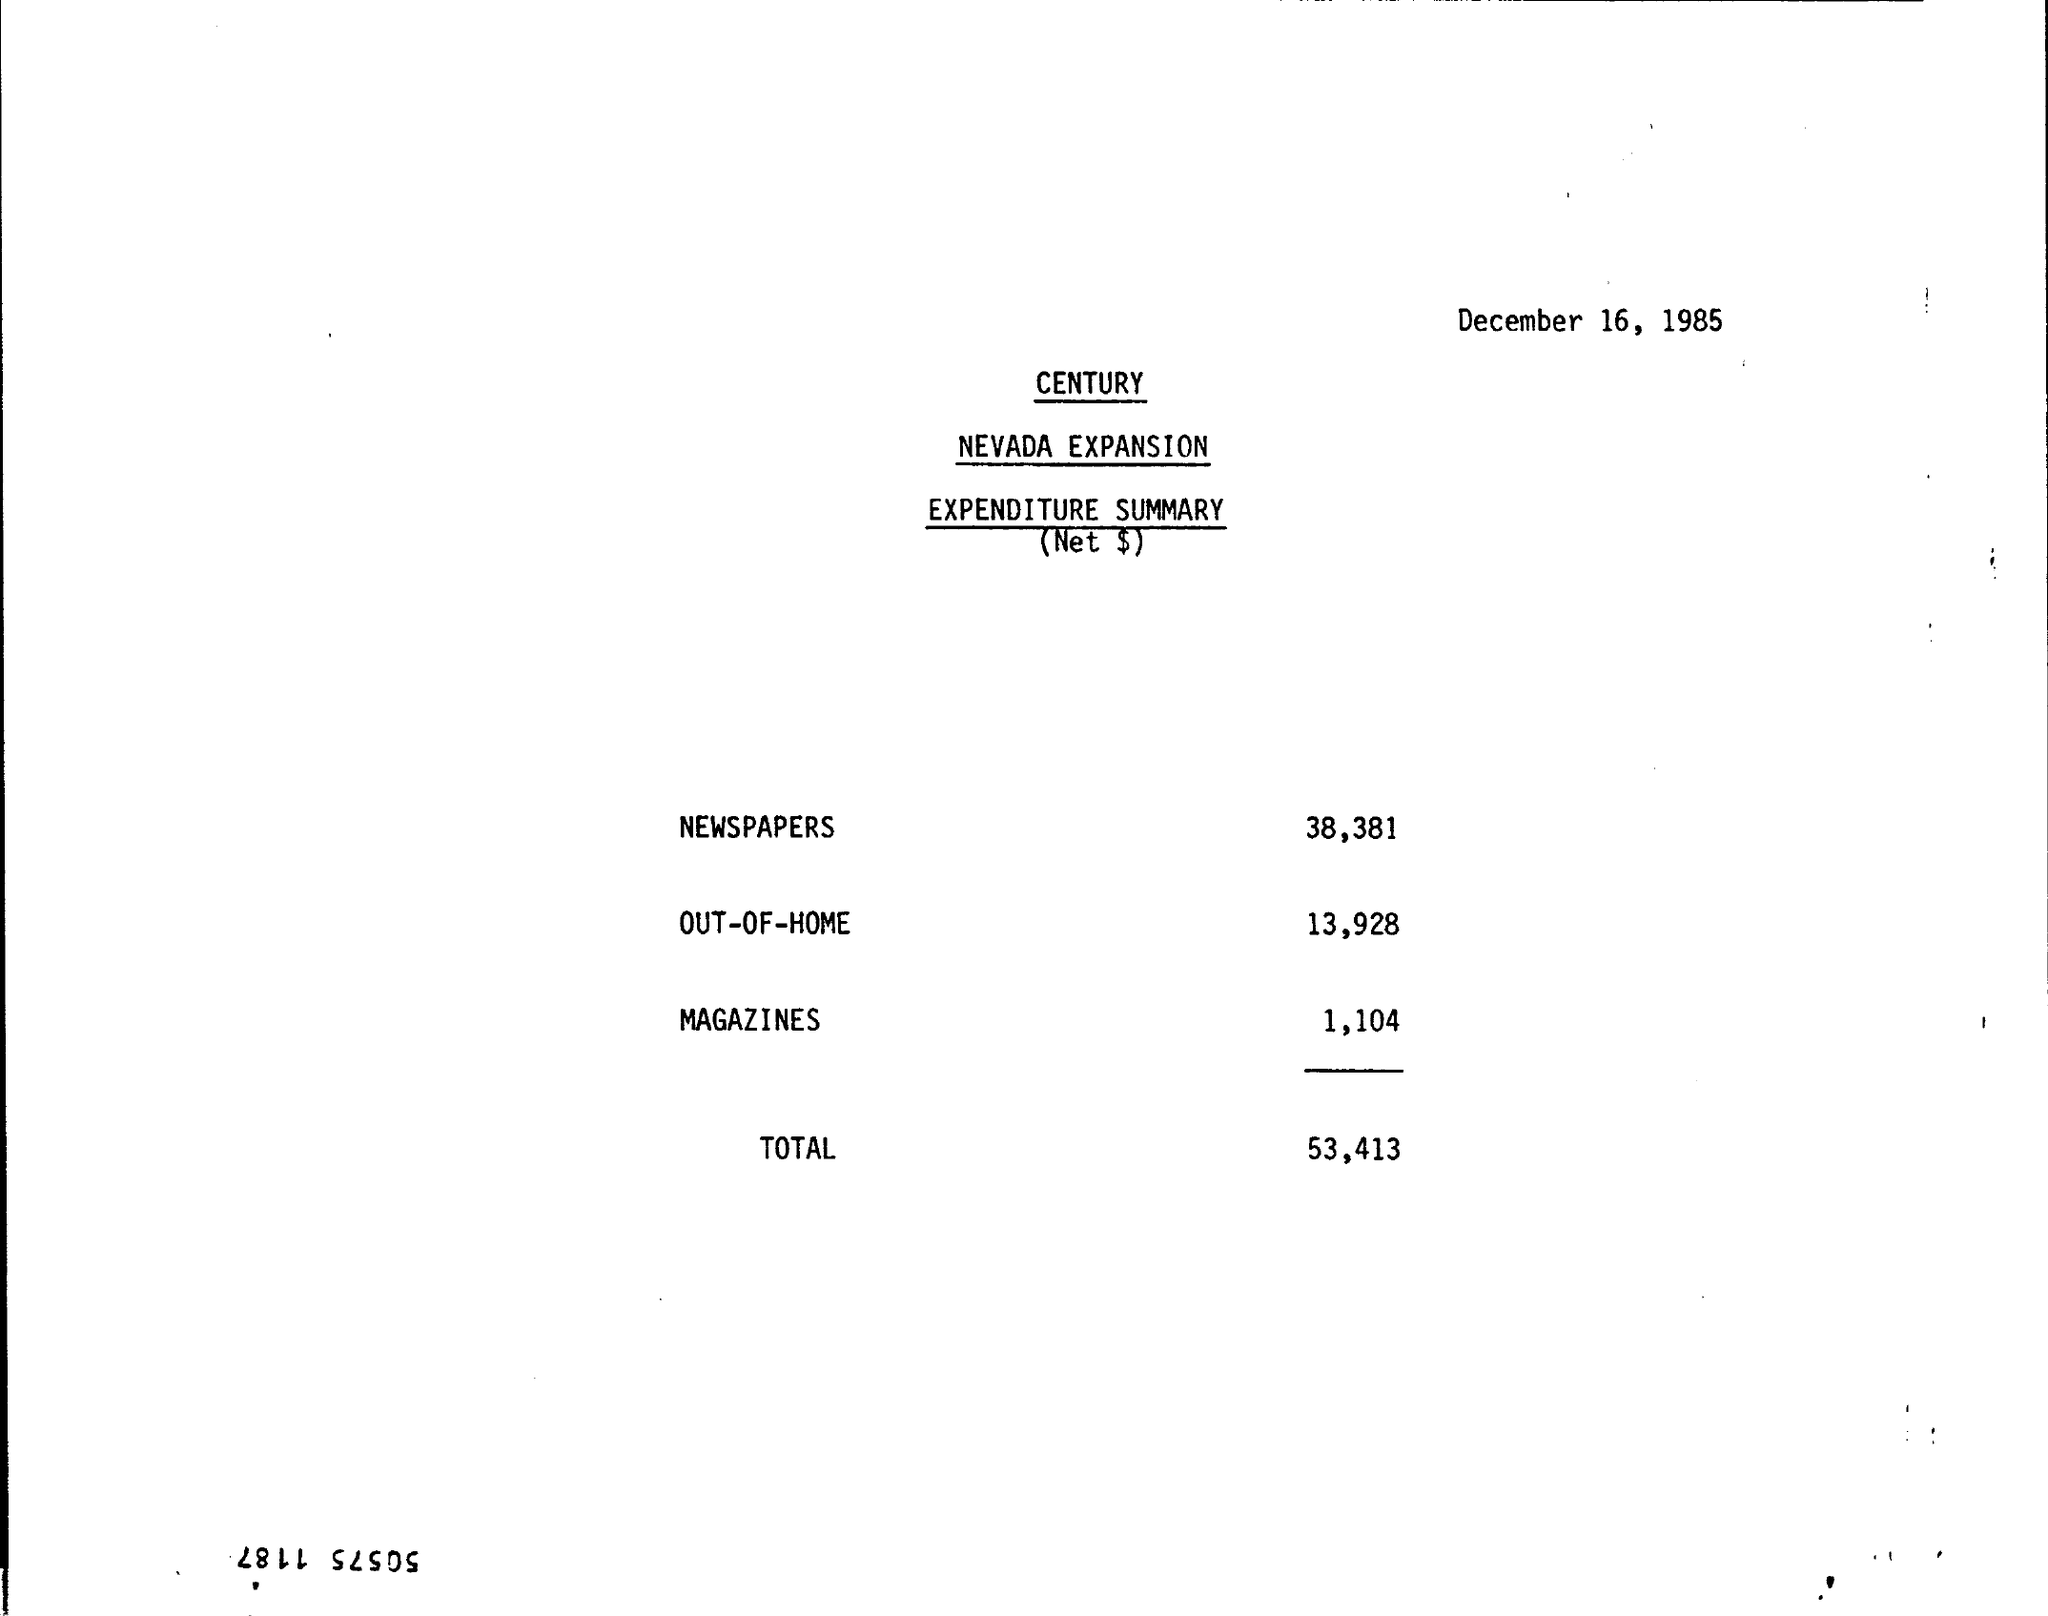What is the Newspaper expense ?
Provide a short and direct response. 38,381. What is the OUT-OF-HOME expense ?
Give a very brief answer. 13,928. What is the Magazines expense ?
Your answer should be compact. 1,104. What is the total expense ?
Offer a terse response. 53,413. 